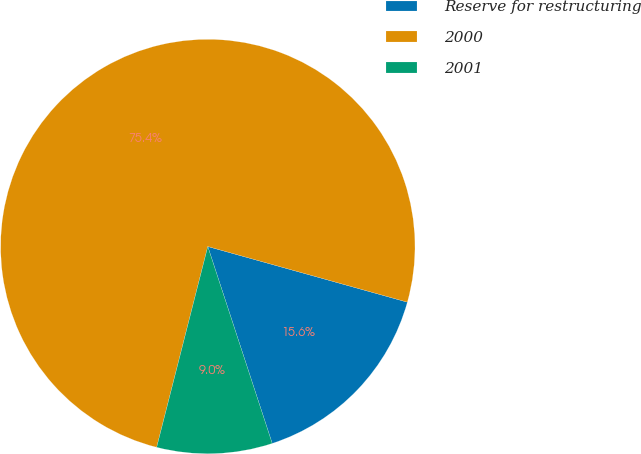Convert chart to OTSL. <chart><loc_0><loc_0><loc_500><loc_500><pie_chart><fcel>Reserve for restructuring<fcel>2000<fcel>2001<nl><fcel>15.64%<fcel>75.36%<fcel>9.0%<nl></chart> 